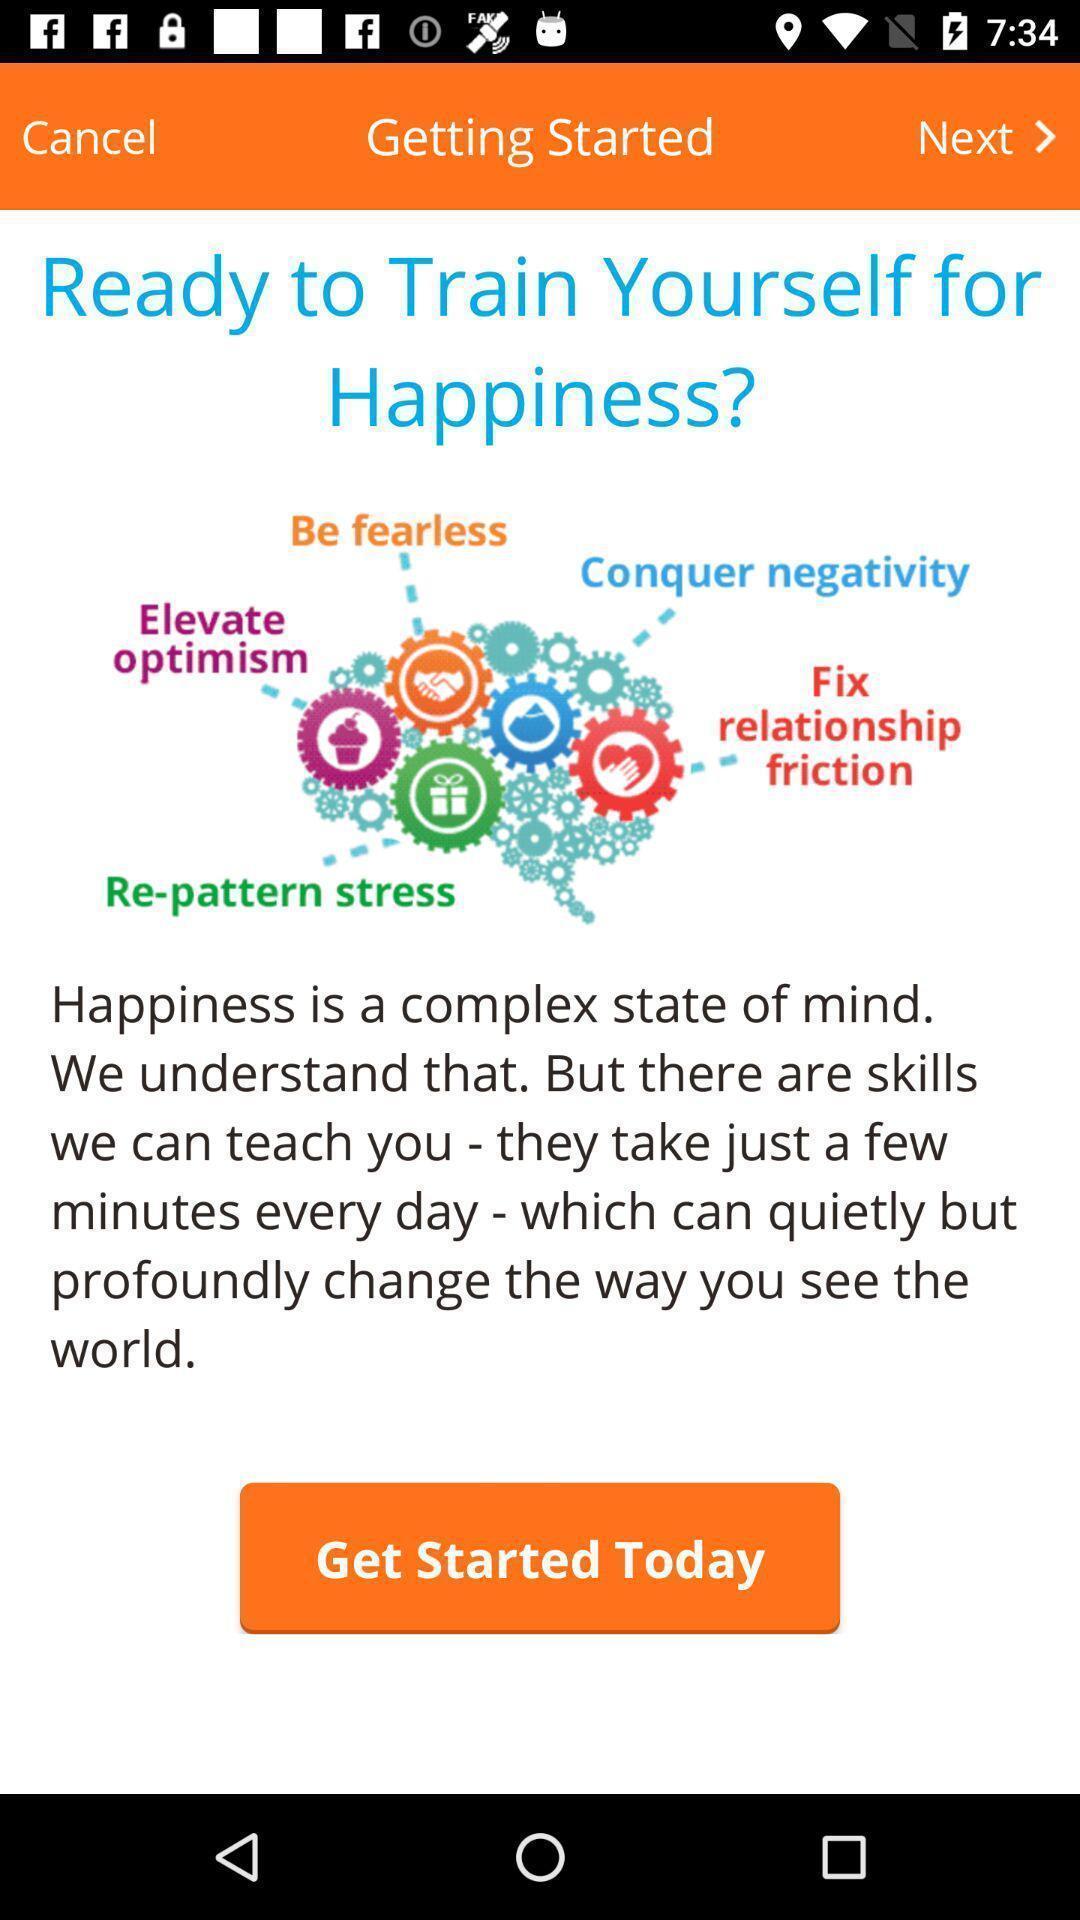Provide a detailed account of this screenshot. Window displaying app is for happiness. 